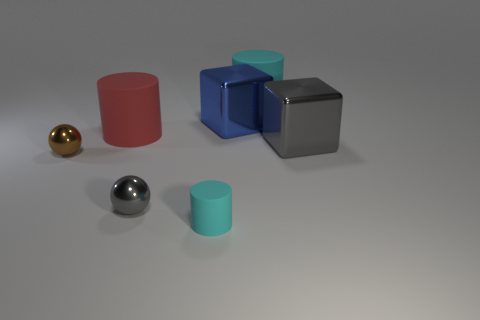There is a gray thing that is in front of the brown object; is its shape the same as the brown object that is on the left side of the blue metal thing?
Offer a terse response. Yes. What material is the big gray thing that is the same shape as the large blue shiny object?
Offer a terse response. Metal. What is the color of the thing that is both on the right side of the tiny gray thing and in front of the brown object?
Give a very brief answer. Cyan. There is a cyan rubber thing in front of the cylinder right of the big blue thing; is there a cylinder on the left side of it?
Give a very brief answer. Yes. What number of objects are either green shiny objects or large red cylinders?
Offer a very short reply. 1. Do the large gray thing and the brown sphere behind the gray shiny ball have the same material?
Offer a very short reply. Yes. What number of objects are either blue blocks that are to the right of the tiny cyan cylinder or matte things left of the large cyan cylinder?
Your answer should be compact. 3. There is a metallic object that is right of the red cylinder and on the left side of the small cyan thing; what shape is it?
Give a very brief answer. Sphere. There is a gray metallic object in front of the large gray shiny block; what number of large cyan matte objects are in front of it?
Keep it short and to the point. 0. What number of things are big metallic blocks on the left side of the big cyan matte thing or metallic spheres?
Make the answer very short. 3. 